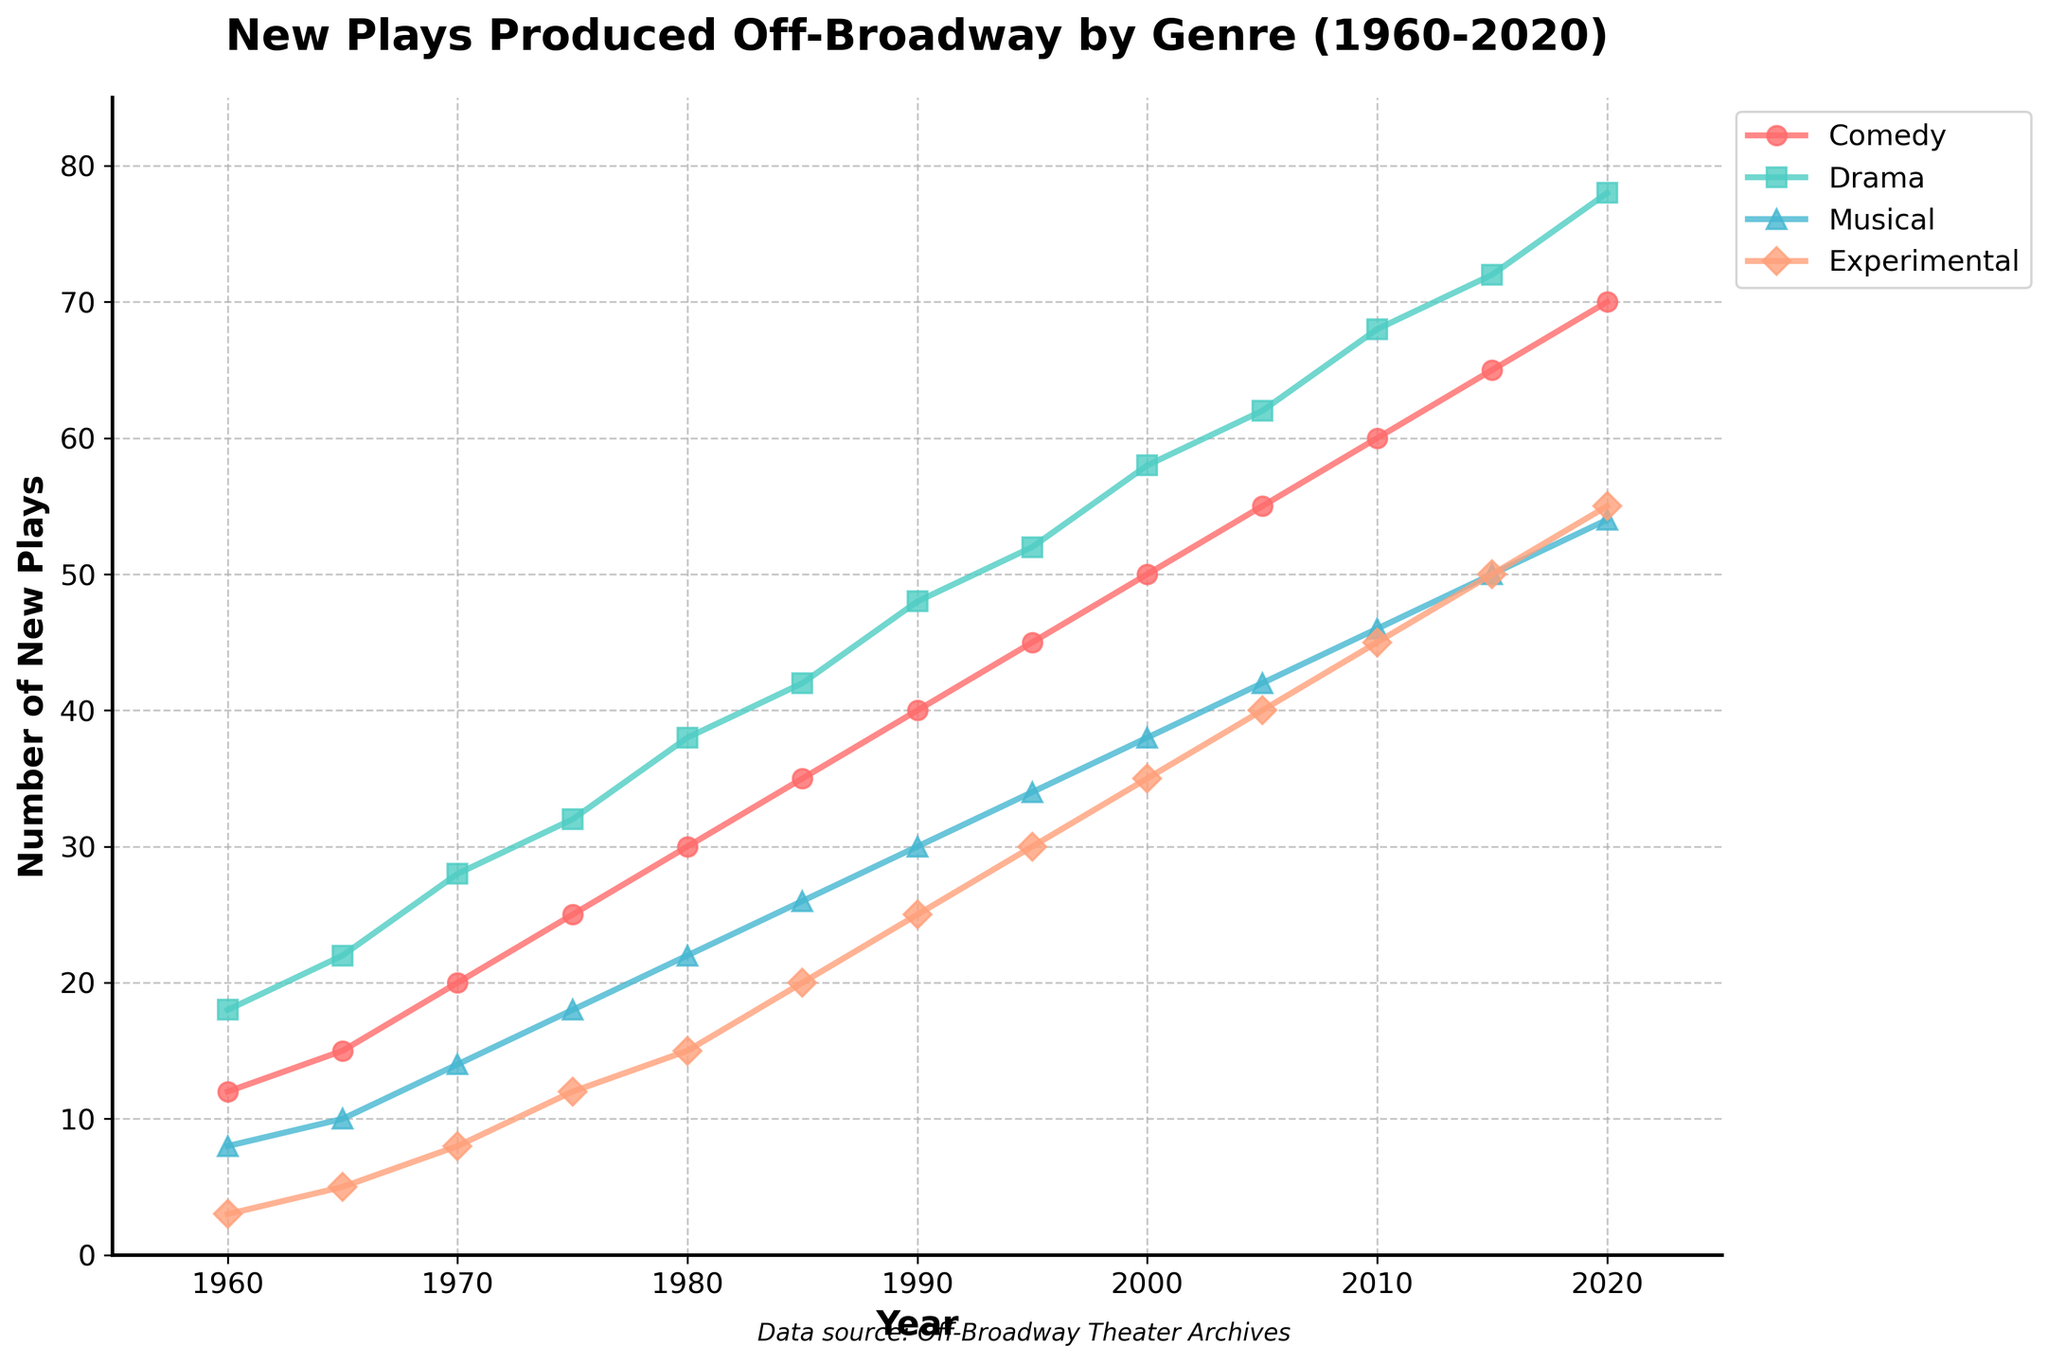Which genre saw the highest increase in the number of new plays produced from 1960 to 2020? To determine the genre with the highest increase, we need to find the difference between the number of new plays produced in 2020 and 1960 for each genre. 
Comedy: 70 - 12 = 58 
Drama: 78 - 18 = 60 
Musical: 54 - 8 = 46 
Experimental: 55 - 3 = 52 
Drama saw the highest increase with 60 more plays produced in 2020 compared to 1960.
Answer: Drama Which genre had the smallest number of new plays produced in 1975? Looking at the data points for 1975, we see the number of new plays for each genre: 
Comedy: 25 
Drama: 32 
Musical: 18 
Experimental: 12 
The smallest number is 12 for Experimental.
Answer: Experimental What was the total number of new plays produced across all genres in 1980? Summing the number of new plays produced in each genre in 1980: 
Comedy: 30 
Drama: 38 
Musical: 22 
Experimental: 15 
Total: 30 + 38 + 22 + 15 = 105
Answer: 105 Has the number of new musicals produced off-Broadway surpassed 50 in any year from 1960 to 2020? From the data, we check the number of new musicals produced each year:
1960: 8 
1965: 10 
1970: 14 
1975: 18 
1980: 22 
1985: 26 
1990: 30 
1995: 34 
2000: 38 
2005: 42 
2010: 46 
2015: 50 
2020: 54 
In 2020, the number of new musicals produced reached 54, which is more than 50.
Answer: Yes In which decade did the number of new Experimental plays see the biggest jump? We need to compare the number of new Experimental plays produced at each decade's start and end:
1960-1970: 8 - 3 = 5 
1970-1980: 15 - 8 = 7 
1980-1990: 25 - 15 = 10 
1990-2000: 35 - 25 = 10 
2000-2010: 45 - 35 = 10 
2010-2020: 55 - 45 = 10 
The biggest jump occurred in the decades from 1980-1990, 1990-2000, 2000-2010, and 2010-2020, all with an increase of 10 plays.
Answer: 1980-1990, 1990-2000, 2000-2010, 2010-2020 Which genre's growth rate slowed down the most between 2010 and 2020 compared to the previous decade? We calculate the increase for each decade:
Comedy: 
2000-2010: 60 - 50 = 10 
2010-2020: 70 - 60 = 10 
Drama: 
2000-2010: 68 - 58 = 10 
2010-2020: 78 - 68 = 10 
Musical: 
2000-2010: 46 - 38 = 8 
2010-2020: 54 - 46 = 8 
Experimental: 
2000-2010: 45 - 35 = 10 
2010-2020: 55 - 45 = 10 
No genre's growth rate slowed down; all had consistent or the same growth.
Answer: None By how many plays did the number of new Comedies produced increase between 2000 and 2020? To find the increase, subtract the number of new Comedies in 2000 from 2020:
2020: 70 
2000: 50 
70 - 50 = 20
Answer: 20 